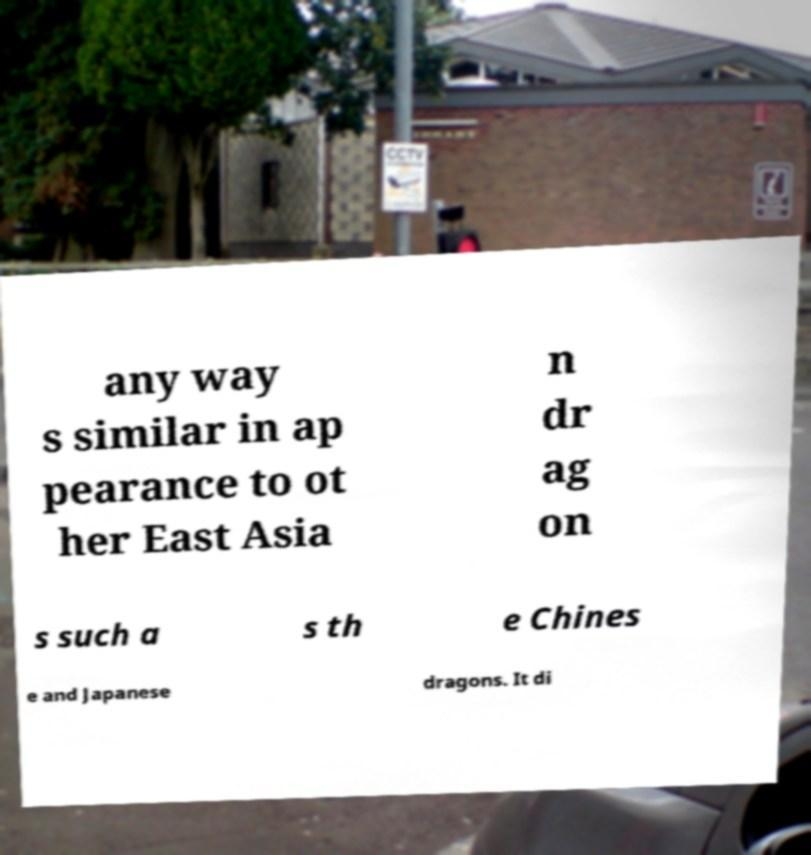Could you assist in decoding the text presented in this image and type it out clearly? any way s similar in ap pearance to ot her East Asia n dr ag on s such a s th e Chines e and Japanese dragons. It di 